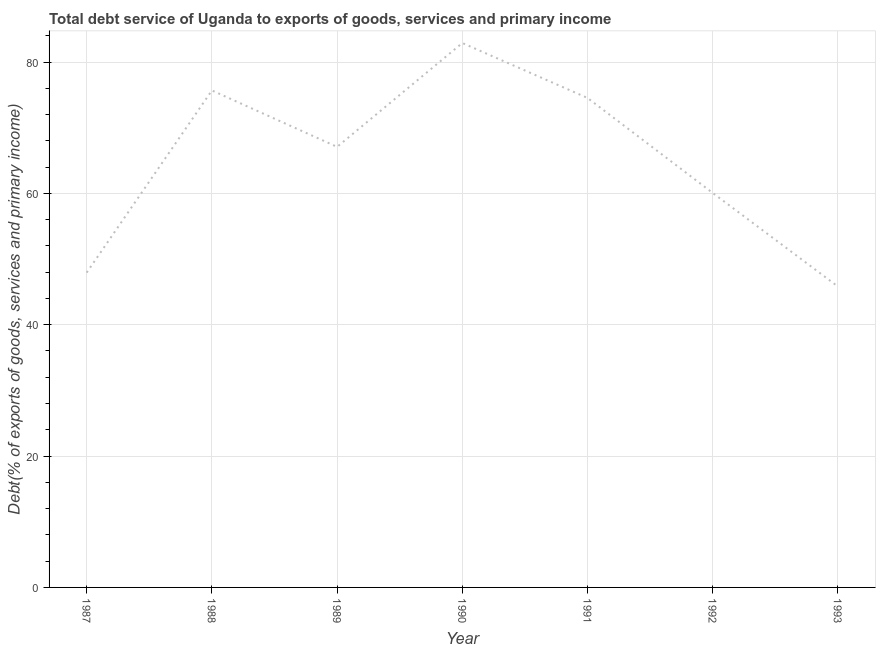What is the total debt service in 1988?
Provide a short and direct response. 75.67. Across all years, what is the maximum total debt service?
Provide a short and direct response. 82.89. Across all years, what is the minimum total debt service?
Your answer should be compact. 45.81. In which year was the total debt service maximum?
Offer a terse response. 1990. In which year was the total debt service minimum?
Offer a terse response. 1993. What is the sum of the total debt service?
Give a very brief answer. 453.97. What is the difference between the total debt service in 1990 and 1993?
Offer a very short reply. 37.08. What is the average total debt service per year?
Keep it short and to the point. 64.85. What is the median total debt service?
Provide a succinct answer. 67.08. In how many years, is the total debt service greater than 12 %?
Provide a succinct answer. 7. What is the ratio of the total debt service in 1990 to that in 1991?
Offer a terse response. 1.11. Is the total debt service in 1988 less than that in 1993?
Provide a short and direct response. No. What is the difference between the highest and the second highest total debt service?
Provide a succinct answer. 7.22. What is the difference between the highest and the lowest total debt service?
Offer a very short reply. 37.08. How many lines are there?
Give a very brief answer. 1. Are the values on the major ticks of Y-axis written in scientific E-notation?
Provide a short and direct response. No. Does the graph contain grids?
Your answer should be very brief. Yes. What is the title of the graph?
Offer a very short reply. Total debt service of Uganda to exports of goods, services and primary income. What is the label or title of the Y-axis?
Keep it short and to the point. Debt(% of exports of goods, services and primary income). What is the Debt(% of exports of goods, services and primary income) in 1987?
Keep it short and to the point. 47.93. What is the Debt(% of exports of goods, services and primary income) in 1988?
Ensure brevity in your answer.  75.67. What is the Debt(% of exports of goods, services and primary income) of 1989?
Offer a terse response. 67.08. What is the Debt(% of exports of goods, services and primary income) of 1990?
Ensure brevity in your answer.  82.89. What is the Debt(% of exports of goods, services and primary income) of 1991?
Your answer should be very brief. 74.53. What is the Debt(% of exports of goods, services and primary income) in 1992?
Your response must be concise. 60.06. What is the Debt(% of exports of goods, services and primary income) of 1993?
Provide a succinct answer. 45.81. What is the difference between the Debt(% of exports of goods, services and primary income) in 1987 and 1988?
Give a very brief answer. -27.74. What is the difference between the Debt(% of exports of goods, services and primary income) in 1987 and 1989?
Your answer should be compact. -19.14. What is the difference between the Debt(% of exports of goods, services and primary income) in 1987 and 1990?
Make the answer very short. -34.96. What is the difference between the Debt(% of exports of goods, services and primary income) in 1987 and 1991?
Offer a very short reply. -26.59. What is the difference between the Debt(% of exports of goods, services and primary income) in 1987 and 1992?
Offer a terse response. -12.13. What is the difference between the Debt(% of exports of goods, services and primary income) in 1987 and 1993?
Offer a very short reply. 2.12. What is the difference between the Debt(% of exports of goods, services and primary income) in 1988 and 1989?
Give a very brief answer. 8.59. What is the difference between the Debt(% of exports of goods, services and primary income) in 1988 and 1990?
Offer a terse response. -7.22. What is the difference between the Debt(% of exports of goods, services and primary income) in 1988 and 1991?
Offer a very short reply. 1.14. What is the difference between the Debt(% of exports of goods, services and primary income) in 1988 and 1992?
Offer a very short reply. 15.61. What is the difference between the Debt(% of exports of goods, services and primary income) in 1988 and 1993?
Keep it short and to the point. 29.86. What is the difference between the Debt(% of exports of goods, services and primary income) in 1989 and 1990?
Ensure brevity in your answer.  -15.81. What is the difference between the Debt(% of exports of goods, services and primary income) in 1989 and 1991?
Your answer should be compact. -7.45. What is the difference between the Debt(% of exports of goods, services and primary income) in 1989 and 1992?
Offer a very short reply. 7.02. What is the difference between the Debt(% of exports of goods, services and primary income) in 1989 and 1993?
Offer a very short reply. 21.26. What is the difference between the Debt(% of exports of goods, services and primary income) in 1990 and 1991?
Provide a succinct answer. 8.37. What is the difference between the Debt(% of exports of goods, services and primary income) in 1990 and 1992?
Offer a terse response. 22.83. What is the difference between the Debt(% of exports of goods, services and primary income) in 1990 and 1993?
Make the answer very short. 37.08. What is the difference between the Debt(% of exports of goods, services and primary income) in 1991 and 1992?
Your answer should be compact. 14.46. What is the difference between the Debt(% of exports of goods, services and primary income) in 1991 and 1993?
Make the answer very short. 28.71. What is the difference between the Debt(% of exports of goods, services and primary income) in 1992 and 1993?
Your response must be concise. 14.25. What is the ratio of the Debt(% of exports of goods, services and primary income) in 1987 to that in 1988?
Give a very brief answer. 0.63. What is the ratio of the Debt(% of exports of goods, services and primary income) in 1987 to that in 1989?
Your answer should be very brief. 0.71. What is the ratio of the Debt(% of exports of goods, services and primary income) in 1987 to that in 1990?
Offer a very short reply. 0.58. What is the ratio of the Debt(% of exports of goods, services and primary income) in 1987 to that in 1991?
Your response must be concise. 0.64. What is the ratio of the Debt(% of exports of goods, services and primary income) in 1987 to that in 1992?
Keep it short and to the point. 0.8. What is the ratio of the Debt(% of exports of goods, services and primary income) in 1987 to that in 1993?
Provide a short and direct response. 1.05. What is the ratio of the Debt(% of exports of goods, services and primary income) in 1988 to that in 1989?
Offer a terse response. 1.13. What is the ratio of the Debt(% of exports of goods, services and primary income) in 1988 to that in 1991?
Keep it short and to the point. 1.01. What is the ratio of the Debt(% of exports of goods, services and primary income) in 1988 to that in 1992?
Keep it short and to the point. 1.26. What is the ratio of the Debt(% of exports of goods, services and primary income) in 1988 to that in 1993?
Offer a terse response. 1.65. What is the ratio of the Debt(% of exports of goods, services and primary income) in 1989 to that in 1990?
Your answer should be compact. 0.81. What is the ratio of the Debt(% of exports of goods, services and primary income) in 1989 to that in 1992?
Your response must be concise. 1.12. What is the ratio of the Debt(% of exports of goods, services and primary income) in 1989 to that in 1993?
Offer a terse response. 1.46. What is the ratio of the Debt(% of exports of goods, services and primary income) in 1990 to that in 1991?
Offer a terse response. 1.11. What is the ratio of the Debt(% of exports of goods, services and primary income) in 1990 to that in 1992?
Ensure brevity in your answer.  1.38. What is the ratio of the Debt(% of exports of goods, services and primary income) in 1990 to that in 1993?
Your response must be concise. 1.81. What is the ratio of the Debt(% of exports of goods, services and primary income) in 1991 to that in 1992?
Your answer should be compact. 1.24. What is the ratio of the Debt(% of exports of goods, services and primary income) in 1991 to that in 1993?
Keep it short and to the point. 1.63. What is the ratio of the Debt(% of exports of goods, services and primary income) in 1992 to that in 1993?
Keep it short and to the point. 1.31. 